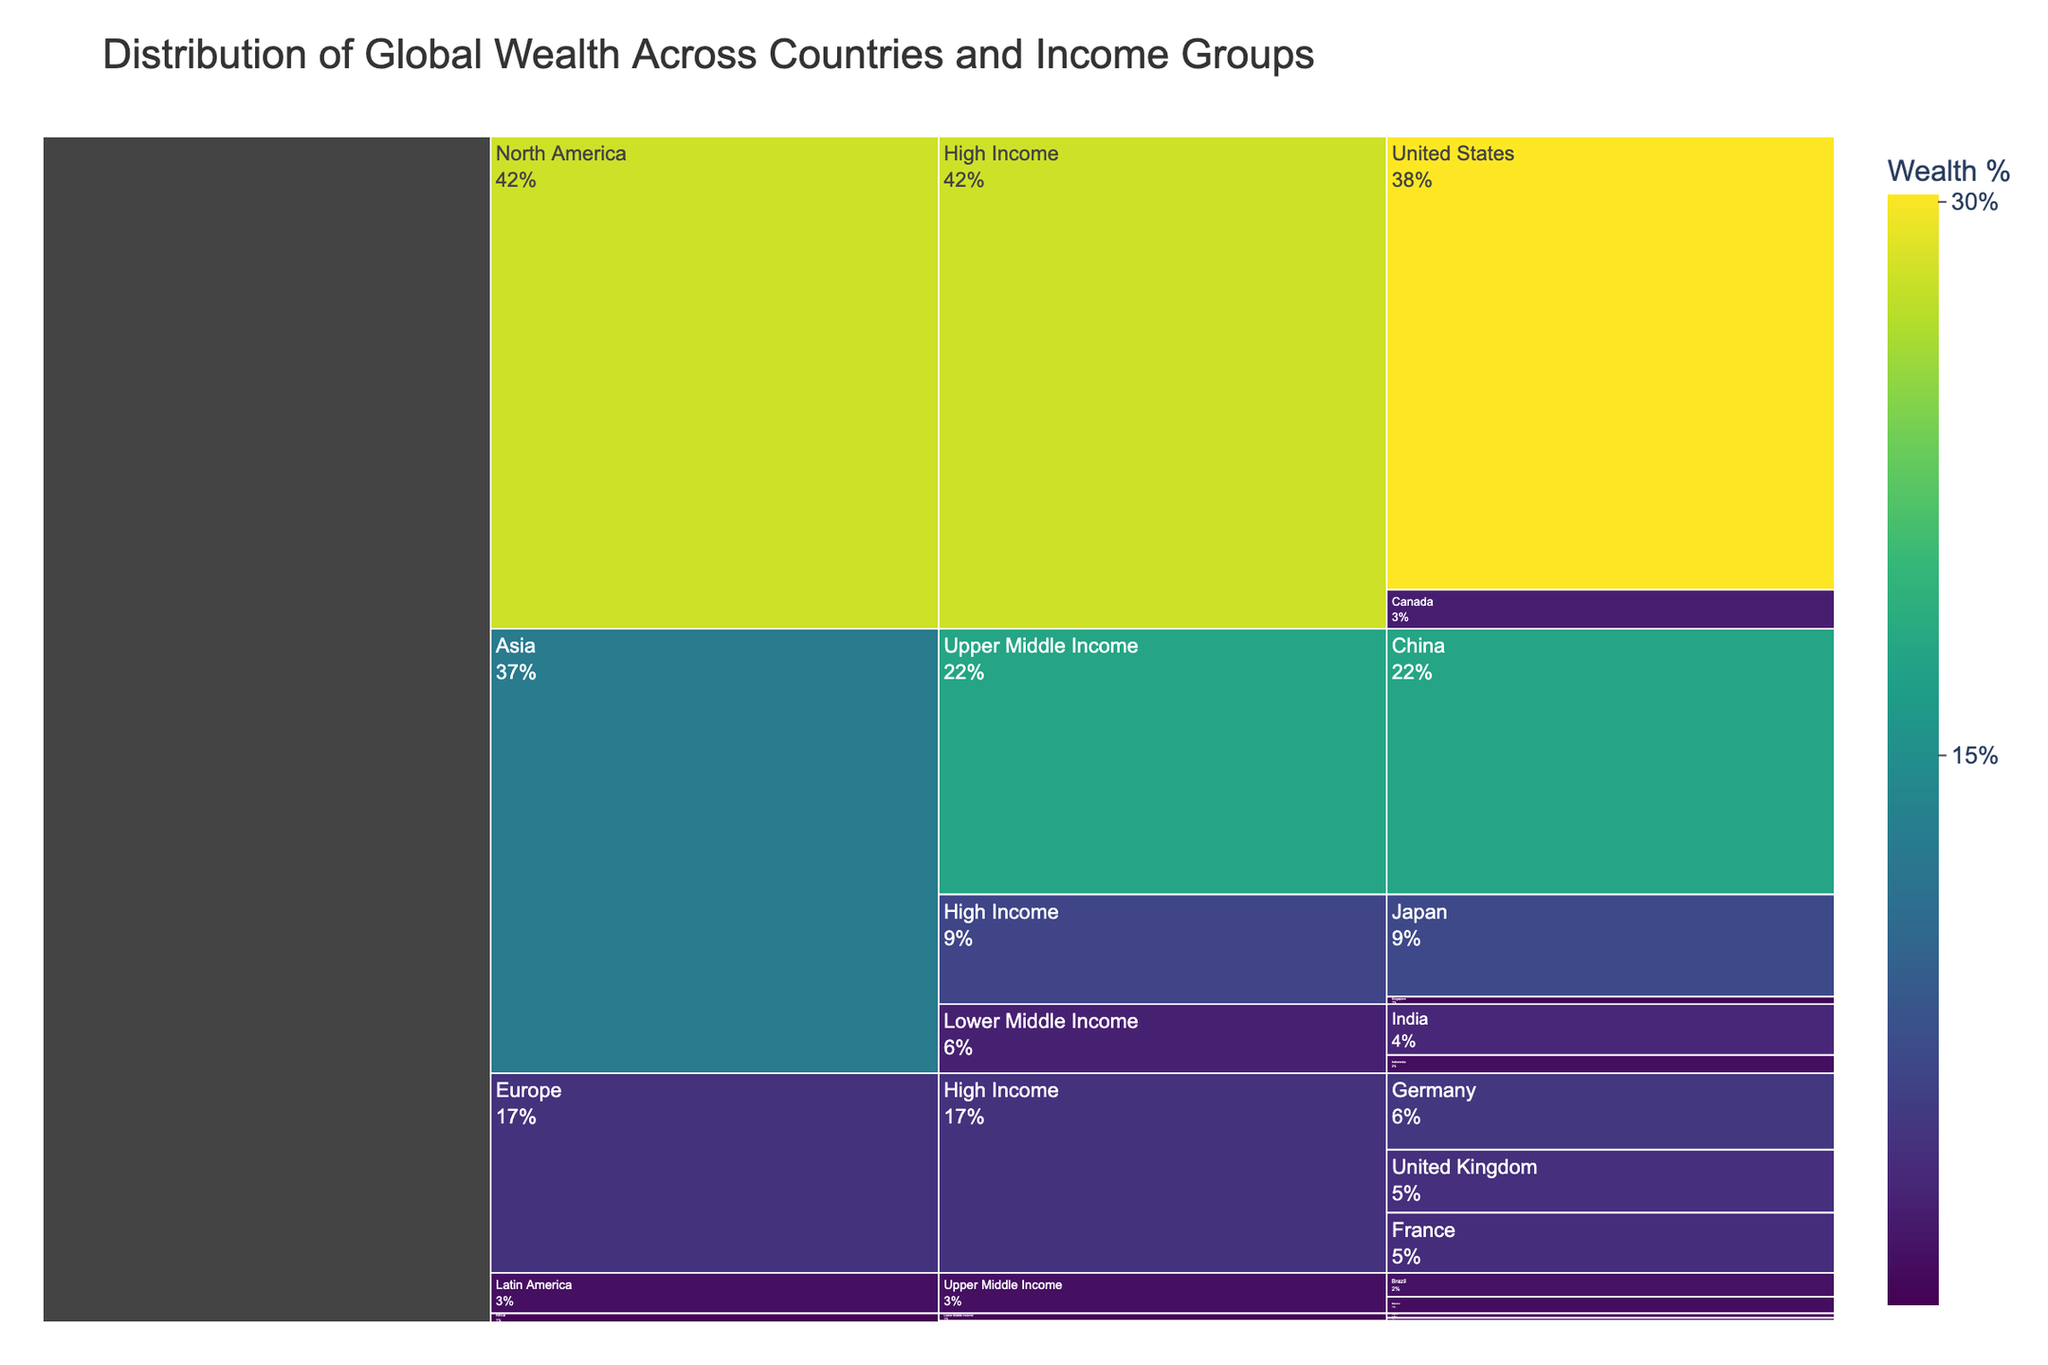How is the chart titled? The chart's title is displayed at the top and is meant to encapsulate the overall theme of the data being visualized. It reads 'Distribution of Global Wealth Across Countries and Income Groups'.
Answer: Distribution of Global Wealth Across Countries and Income Groups Which region has the highest wealth percentage? By examining the segments of the Icicle chart and their corresponding values, the largest segment is for North America, which includes the United States and Canada, summing up to 30.2% + 2.6% = 32.8%.
Answer: North America Which Asian country holds the largest wealth percentage? Comparing the percentage values for all Asian countries in the chart, Japan has 6.8% while China has 17.7%. Since 17.7% is greater, China holds the largest wealth percentage in Asia.
Answer: China What's the combined wealth percentage of the European high-income countries depicted? Summing the values of the European high-income countries: Germany (5.1) + United Kingdom (4.2) + France (4.0) = 13.3%.
Answer: 13.3% What is the percentage difference in wealth between the United States and the adult population of China? The wealth percentage of the United States is 30.2% and that of China is 17.7%. The difference is calculated as 30.2 - 17.7, which equals 12.5%.
Answer: 12.5% Which income group in Africa has the smallest wealth percentage? The chart segments for African countries are broken into income groups, and comparing the percentages, Ethiopia has 0.1%, which is lower than Nigeria (0.3%) and Egypt (0.2%).
Answer: Low Income (Ethiopia) How does the wealth percentage of Japan compare to that of the United Kingdom? According to the chart, Japan’s wealth percentage is 6.8% and the United Kingdom’s is 4.2%. Japan’s value is higher than that of the United Kingdom.
Answer: Japan has a higher percentage What is the total wealth percentage of all countries in Asia? Adding the wealth percentages of Asian countries: Japan (6.8) + Singapore (0.5) + China (17.7) + India (3.4) + Indonesia (1.2) = 29.6%.
Answer: 29.6% Identify the country with the smallest wealth percentage and provide its percentage. Among the countries listed, Ethiopia has the smallest wealth percentage, which is 0.1%.
Answer: Ethiopia, 0.1% How does the combined wealth of high-income countries in North America compare to that of high-income countries in Europe? Total wealth for North American high-income countries: United States (30.2%) + Canada (2.6%) = 32.8%. For European high-income countries: Germany (5.1%) + United Kingdom (4.2%) + France (4%) = 13.3%. Comparing the two, 32.8% is greater than 13.3%.
Answer: North America's high-income countries have a higher combined wealth 